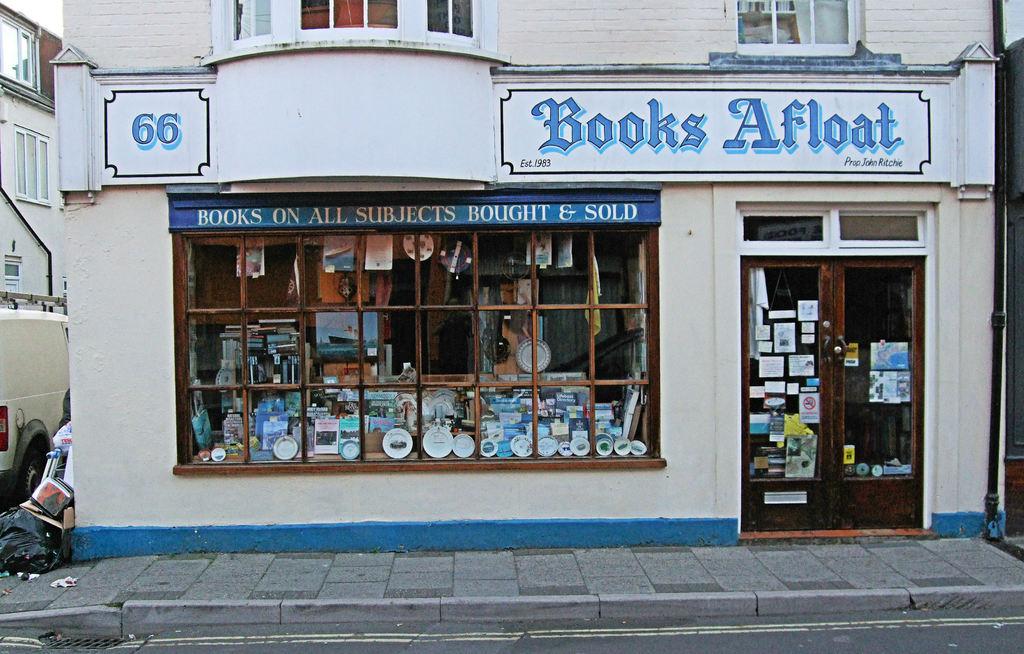What is the name of this store?
Your answer should be very brief. Books afloat. What does it say at the top of the window?
Your response must be concise. Books on all subjects bought & sold. 